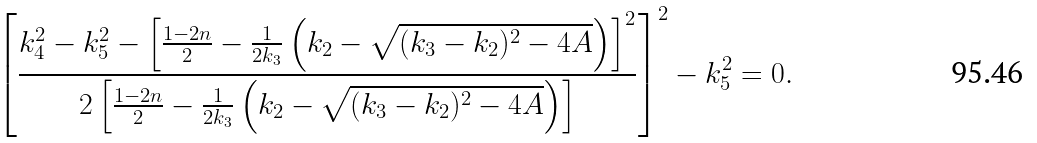Convert formula to latex. <formula><loc_0><loc_0><loc_500><loc_500>\left [ \frac { k _ { 4 } ^ { 2 } - k _ { 5 } ^ { 2 } - \left [ \frac { 1 - 2 n } { 2 } - \frac { 1 } { 2 k _ { 3 } } \left ( k _ { 2 } - \sqrt { ( k _ { 3 } - k _ { 2 } ) ^ { 2 } - 4 A } \right ) \right ] ^ { 2 } } { 2 \left [ \frac { 1 - 2 n } { 2 } - \frac { 1 } { 2 k _ { 3 } } \left ( k _ { 2 } - \sqrt { ( k _ { 3 } - k _ { 2 } ) ^ { 2 } - 4 A } \right ) \right ] } \right ] ^ { 2 } - k _ { 5 } ^ { 2 } = 0 .</formula> 